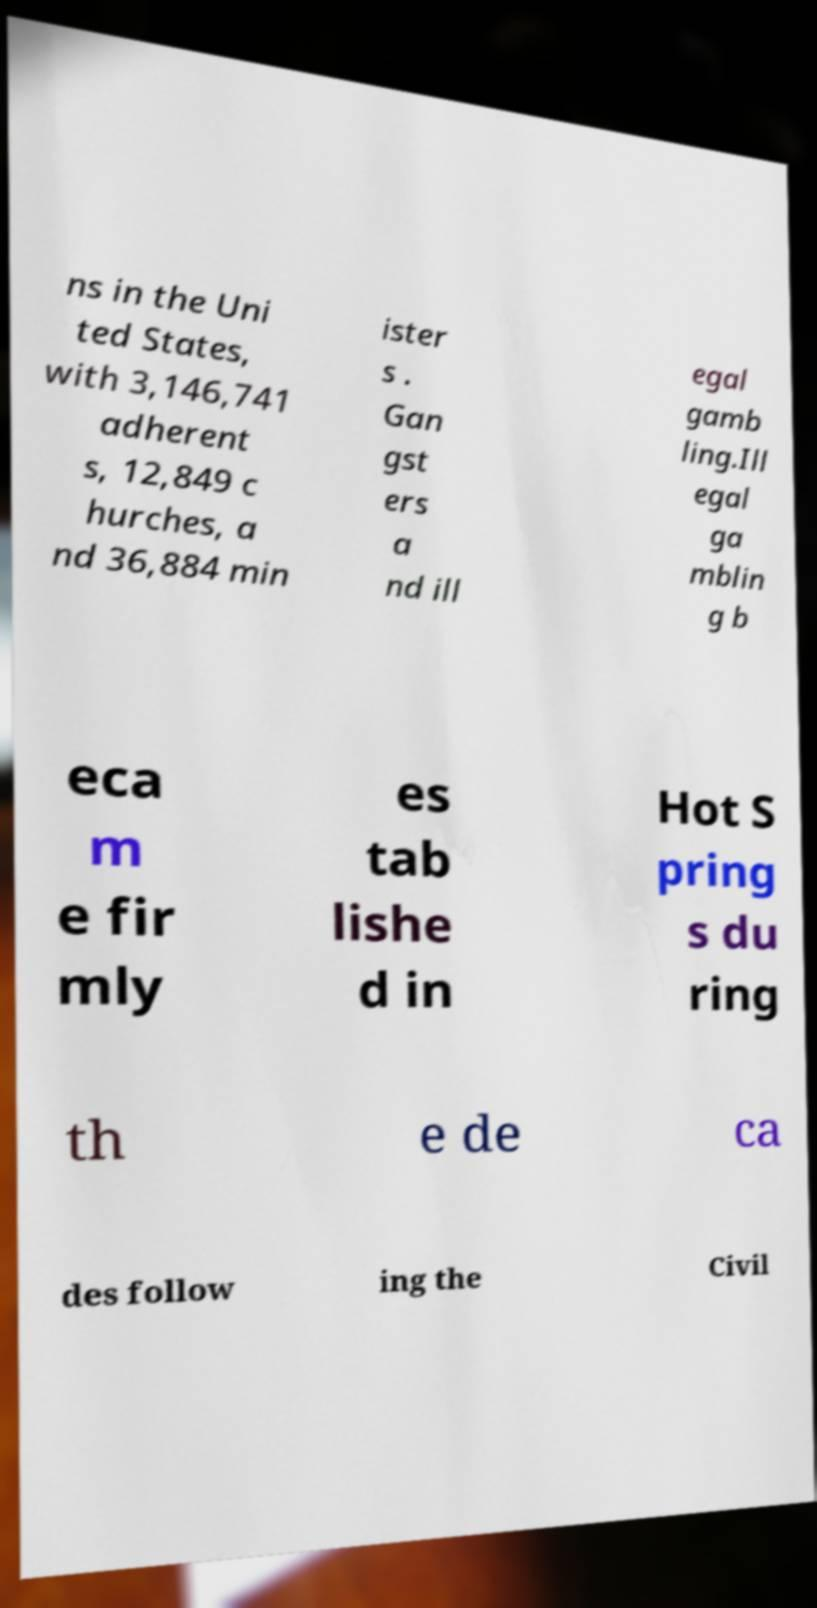Could you assist in decoding the text presented in this image and type it out clearly? ns in the Uni ted States, with 3,146,741 adherent s, 12,849 c hurches, a nd 36,884 min ister s . Gan gst ers a nd ill egal gamb ling.Ill egal ga mblin g b eca m e fir mly es tab lishe d in Hot S pring s du ring th e de ca des follow ing the Civil 